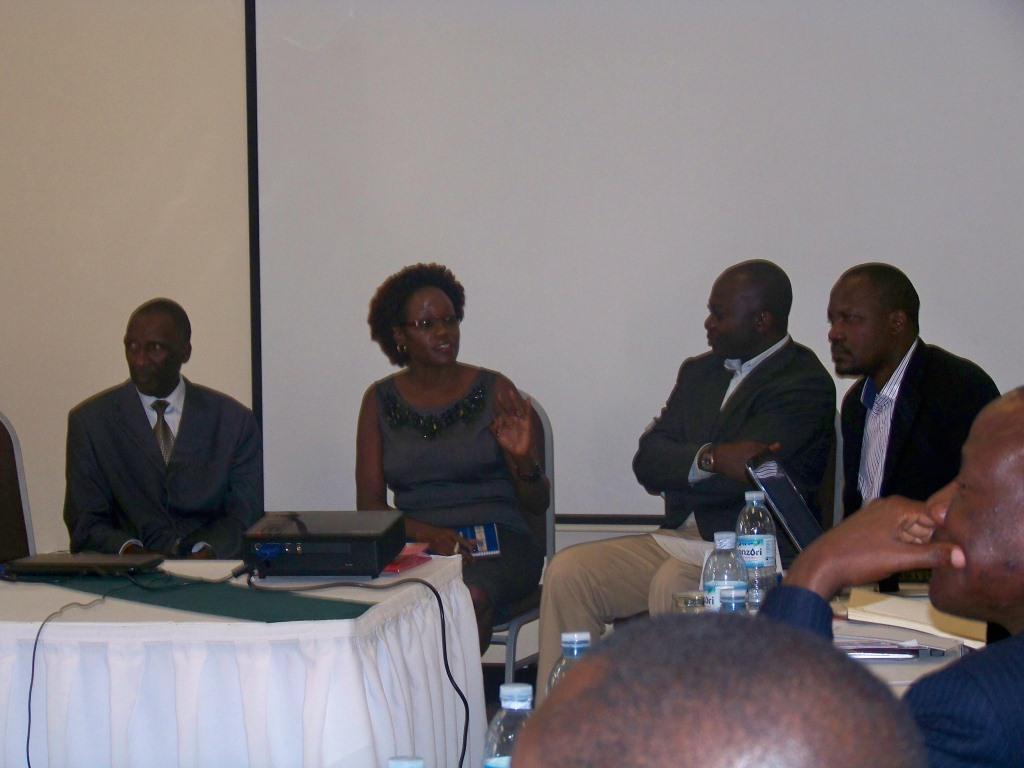Can you describe this image briefly? In this picture there are some people sitting on the chair. In the background there is a screen. There is a lady with the black dress. She is sitting. In front of her there is a table with white cloth. On the table there is a projector and keyboard. And we can see water bottles to the right side. 